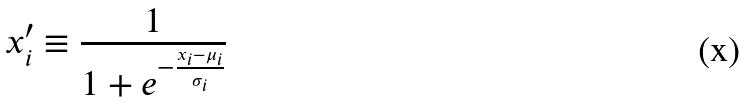Convert formula to latex. <formula><loc_0><loc_0><loc_500><loc_500>x _ { i } ^ { \prime } \equiv \frac { 1 } { 1 + e ^ { - \frac { x _ { i } - \mu _ { i } } { \sigma _ { i } } } }</formula> 